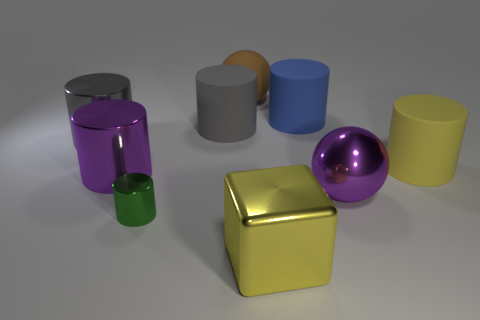Subtract all gray shiny cylinders. How many cylinders are left? 5 Subtract all red balls. How many gray cylinders are left? 2 Subtract all gray cylinders. How many cylinders are left? 4 Subtract all balls. How many objects are left? 7 Subtract 5 cylinders. How many cylinders are left? 1 Subtract all brown cylinders. Subtract all red blocks. How many cylinders are left? 6 Subtract all small yellow rubber blocks. Subtract all big metallic balls. How many objects are left? 8 Add 7 large blue rubber cylinders. How many large blue rubber cylinders are left? 8 Add 1 small gray cylinders. How many small gray cylinders exist? 1 Subtract 0 cyan spheres. How many objects are left? 9 